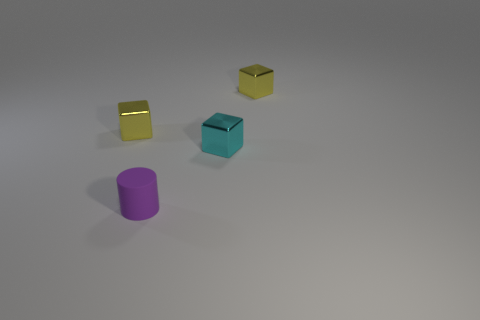What number of small cylinders have the same color as the matte object?
Your answer should be very brief. 0. There is a thing that is behind the tiny cyan metallic block and on the right side of the purple matte object; what shape is it?
Keep it short and to the point. Cube. There is a thing that is both behind the rubber cylinder and on the left side of the tiny cyan metal object; what is its color?
Keep it short and to the point. Yellow. Is the number of yellow cubes that are to the right of the purple matte cylinder greater than the number of cyan metal blocks on the right side of the cyan object?
Offer a very short reply. Yes. There is a shiny cube left of the small cylinder; what color is it?
Ensure brevity in your answer.  Yellow. There is a yellow object to the left of the tiny rubber cylinder; is it the same shape as the tiny purple thing that is in front of the tiny cyan cube?
Offer a very short reply. No. Is there a blue matte sphere that has the same size as the cyan block?
Your answer should be compact. No. What is the material of the yellow cube that is to the left of the tiny cyan shiny object?
Your response must be concise. Metal. Are the tiny cyan object behind the cylinder and the small purple object made of the same material?
Offer a very short reply. No. Are there any green things?
Your response must be concise. No. 